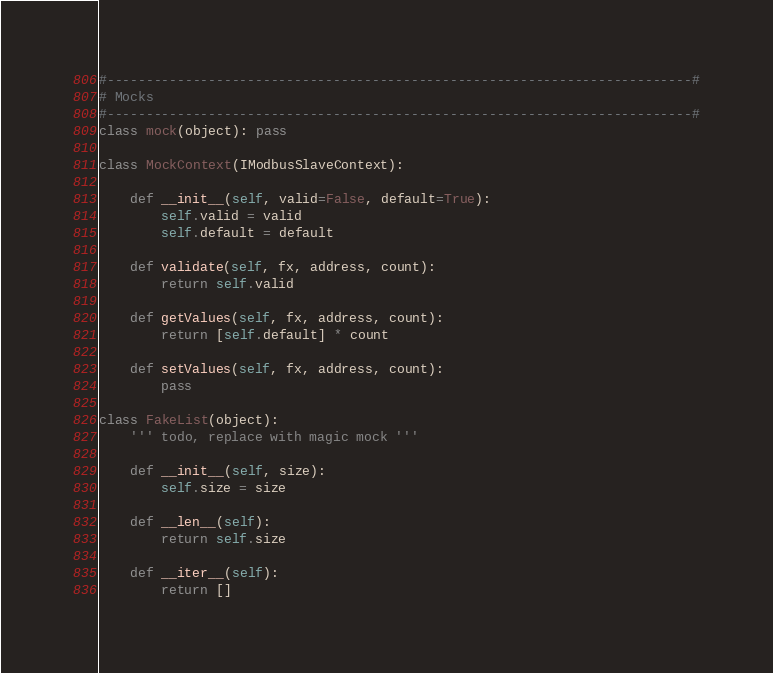Convert code to text. <code><loc_0><loc_0><loc_500><loc_500><_Python_>
#---------------------------------------------------------------------------#
# Mocks
#---------------------------------------------------------------------------#
class mock(object): pass

class MockContext(IModbusSlaveContext):

    def __init__(self, valid=False, default=True):
        self.valid = valid
        self.default = default

    def validate(self, fx, address, count):
        return self.valid

    def getValues(self, fx, address, count):
        return [self.default] * count

    def setValues(self, fx, address, count):
        pass

class FakeList(object):
    ''' todo, replace with magic mock '''

    def __init__(self, size):
        self.size = size

    def __len__(self):
        return self.size

    def __iter__(self):
        return []

</code> 